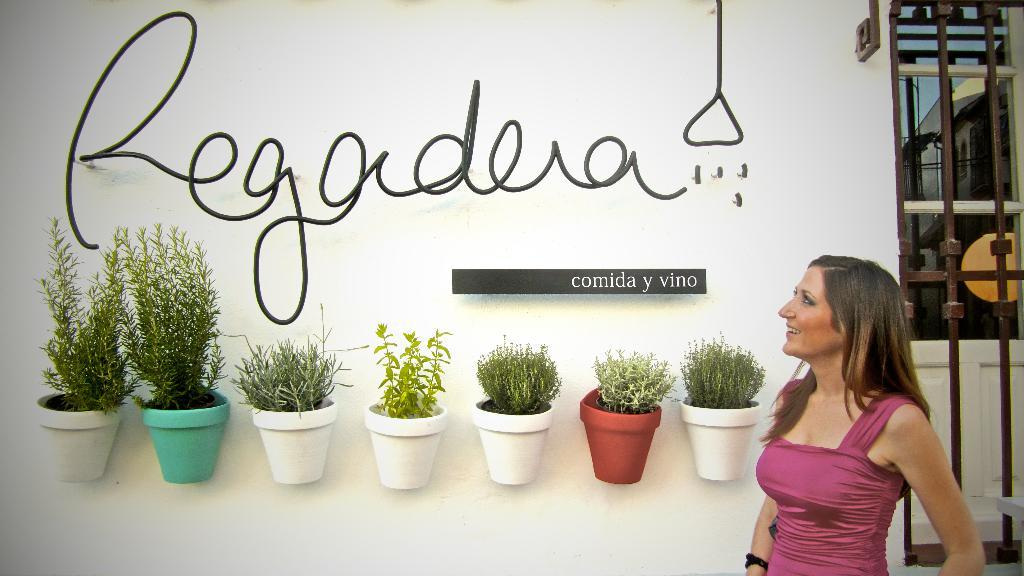Who is present in the image? There is a woman in the image. What is the woman's expression? The woman is smiling. What objects can be seen in the image besides the woman? There are flower pots and rods in the image. What can be seen in the background of the image? There are buildings and the sky visible in the background of the image. How many grapes are on the woman's head in the image? There are no grapes present in the image. What type of ball is being used by the ants in the image? There are no ants or balls present in the image. 